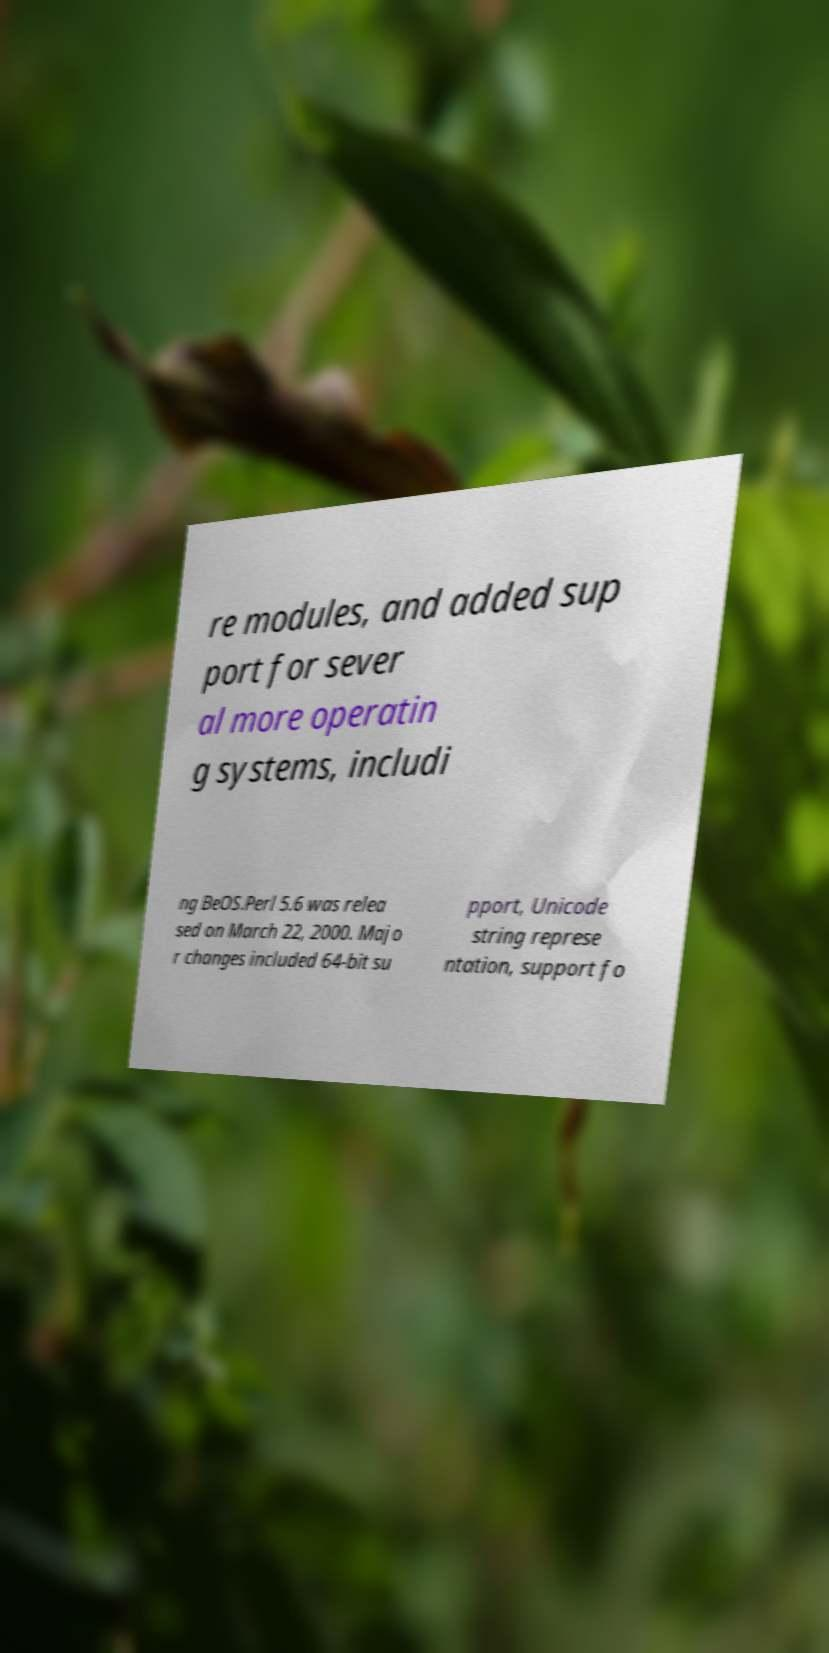Could you assist in decoding the text presented in this image and type it out clearly? re modules, and added sup port for sever al more operatin g systems, includi ng BeOS.Perl 5.6 was relea sed on March 22, 2000. Majo r changes included 64-bit su pport, Unicode string represe ntation, support fo 